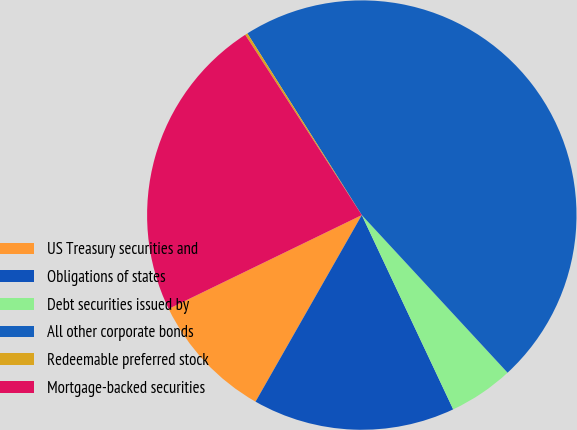<chart> <loc_0><loc_0><loc_500><loc_500><pie_chart><fcel>US Treasury securities and<fcel>Obligations of states<fcel>Debt securities issued by<fcel>All other corporate bonds<fcel>Redeemable preferred stock<fcel>Mortgage-backed securities<nl><fcel>9.57%<fcel>15.24%<fcel>4.88%<fcel>47.07%<fcel>0.19%<fcel>23.06%<nl></chart> 